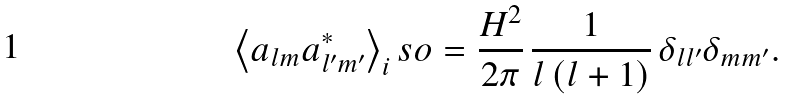<formula> <loc_0><loc_0><loc_500><loc_500>\left < a _ { l m } a ^ { \ast } _ { l ^ { \prime } m ^ { \prime } } \right > _ { i } s o = \frac { H ^ { 2 } } { 2 \pi } \, \frac { 1 } { l \left ( l + 1 \right ) } \, \delta _ { l l ^ { \prime } } \delta _ { m m ^ { \prime } } .</formula> 